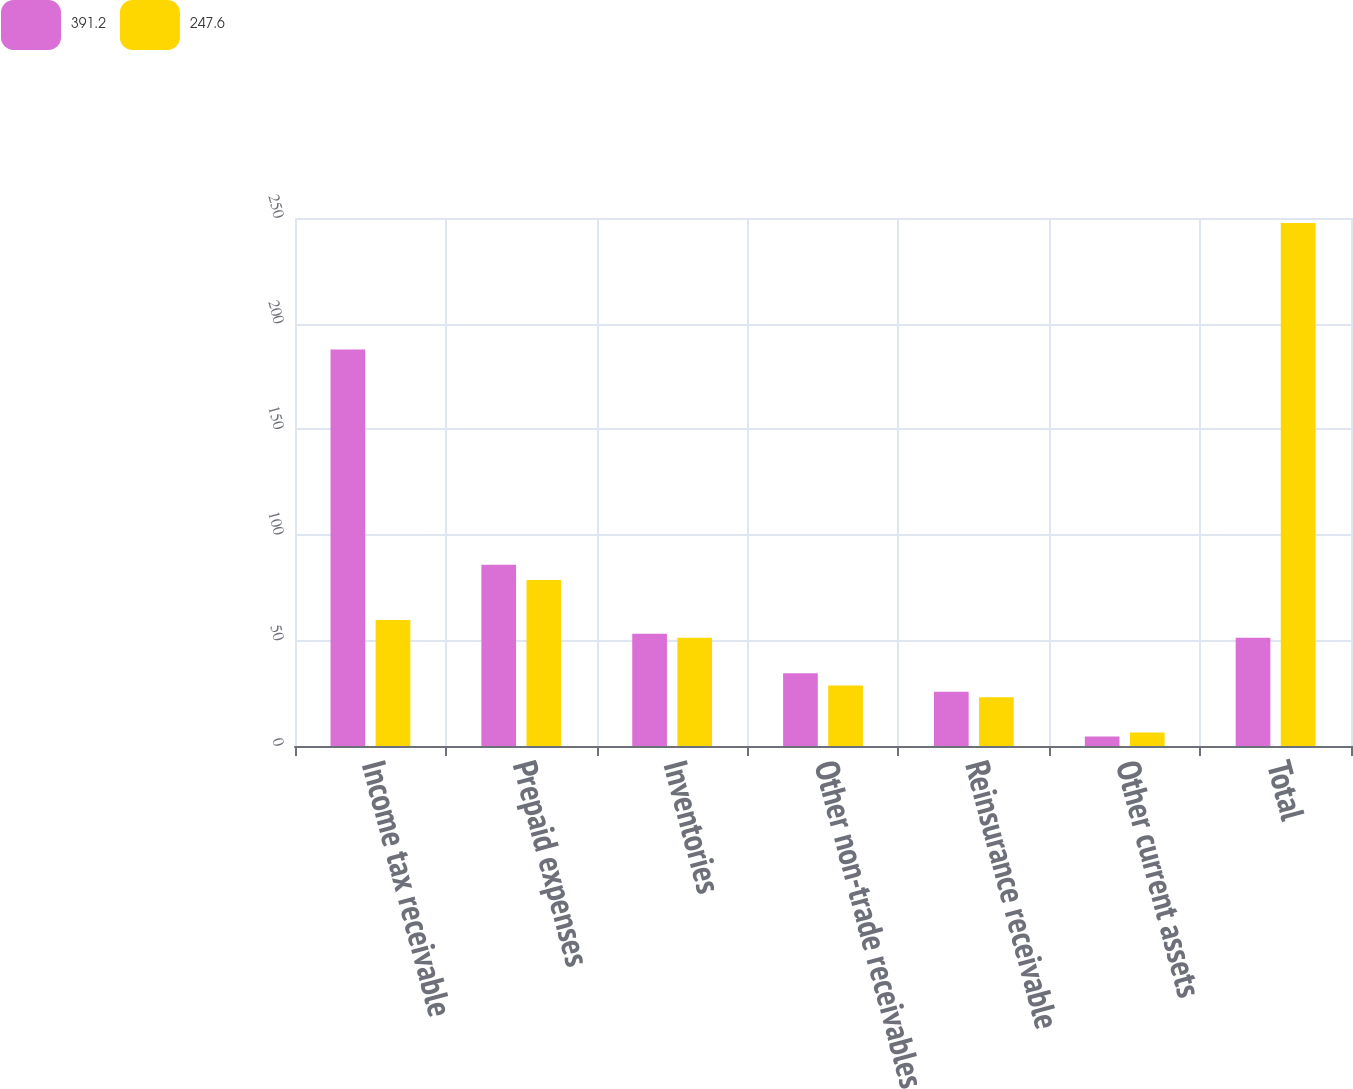<chart> <loc_0><loc_0><loc_500><loc_500><stacked_bar_chart><ecel><fcel>Income tax receivable<fcel>Prepaid expenses<fcel>Inventories<fcel>Other non-trade receivables<fcel>Reinsurance receivable<fcel>Other current assets<fcel>Total<nl><fcel>391.2<fcel>187.7<fcel>85.8<fcel>53.1<fcel>34.4<fcel>25.7<fcel>4.5<fcel>51.2<nl><fcel>247.6<fcel>59.7<fcel>78.6<fcel>51.2<fcel>28.6<fcel>23.1<fcel>6.4<fcel>247.6<nl></chart> 